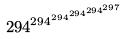Convert formula to latex. <formula><loc_0><loc_0><loc_500><loc_500>2 9 4 ^ { 2 9 4 ^ { 2 9 4 ^ { 2 9 4 ^ { 2 9 4 ^ { 2 9 7 } } } } }</formula> 